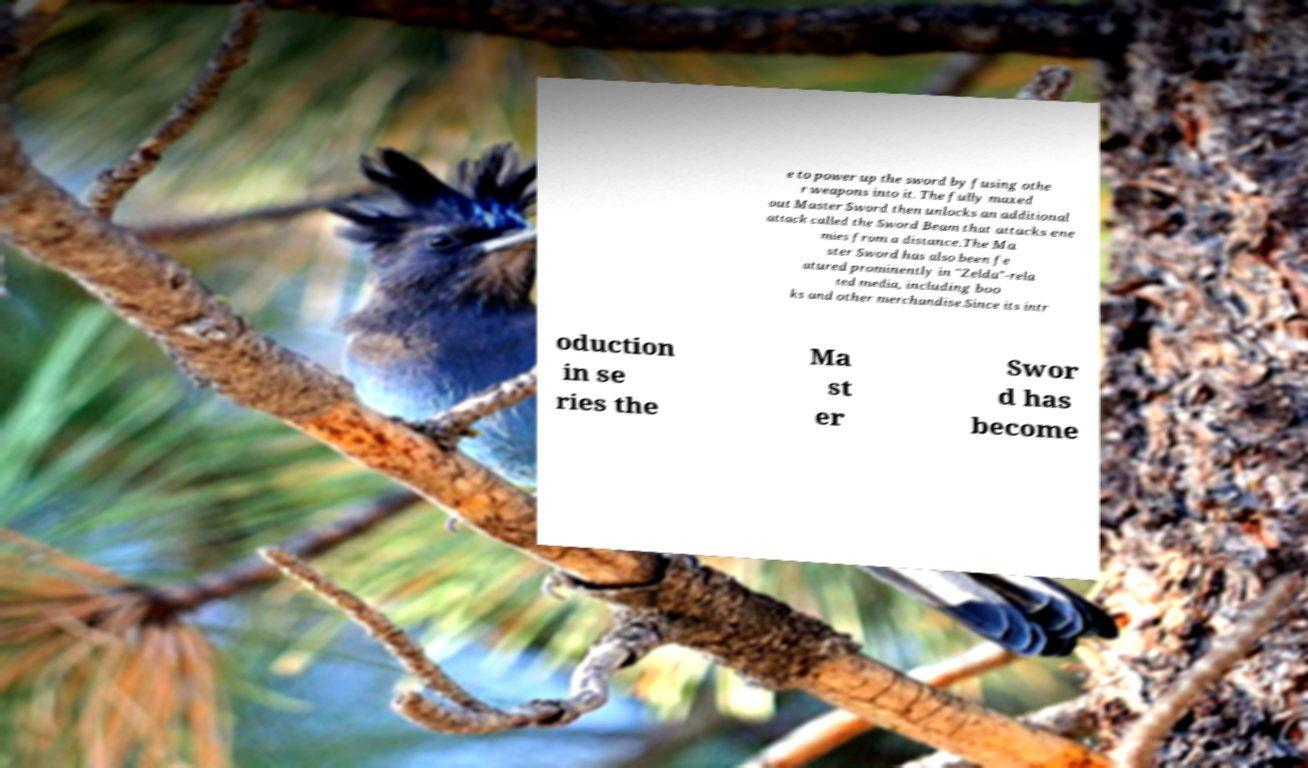I need the written content from this picture converted into text. Can you do that? e to power up the sword by fusing othe r weapons into it. The fully maxed out Master Sword then unlocks an additional attack called the Sword Beam that attacks ene mies from a distance.The Ma ster Sword has also been fe atured prominently in "Zelda"-rela ted media, including boo ks and other merchandise.Since its intr oduction in se ries the Ma st er Swor d has become 